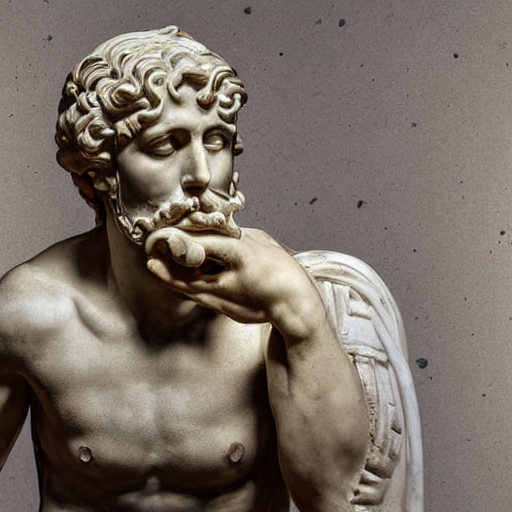How is the focus in the image? The concentration of focus is precise, capturing intricate details such as the texture of the hair and skin, as well as the expression on the statue's face. The background has a slight bokeh effect, subtly emphasizing the subject. 